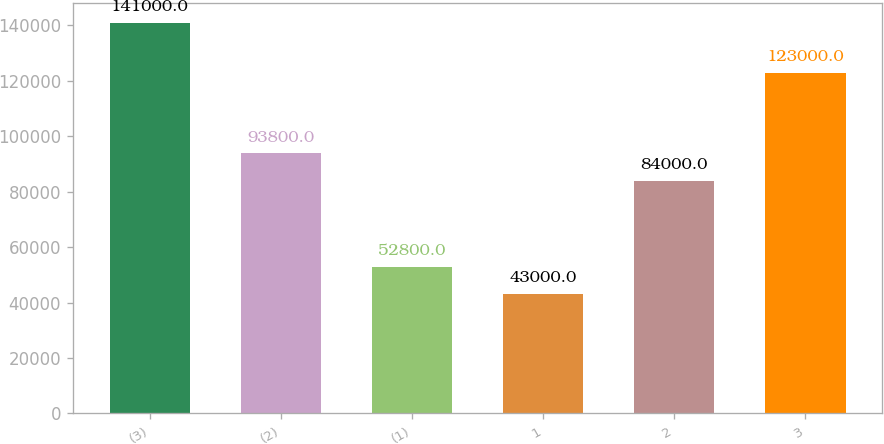<chart> <loc_0><loc_0><loc_500><loc_500><bar_chart><fcel>(3)<fcel>(2)<fcel>(1)<fcel>1<fcel>2<fcel>3<nl><fcel>141000<fcel>93800<fcel>52800<fcel>43000<fcel>84000<fcel>123000<nl></chart> 